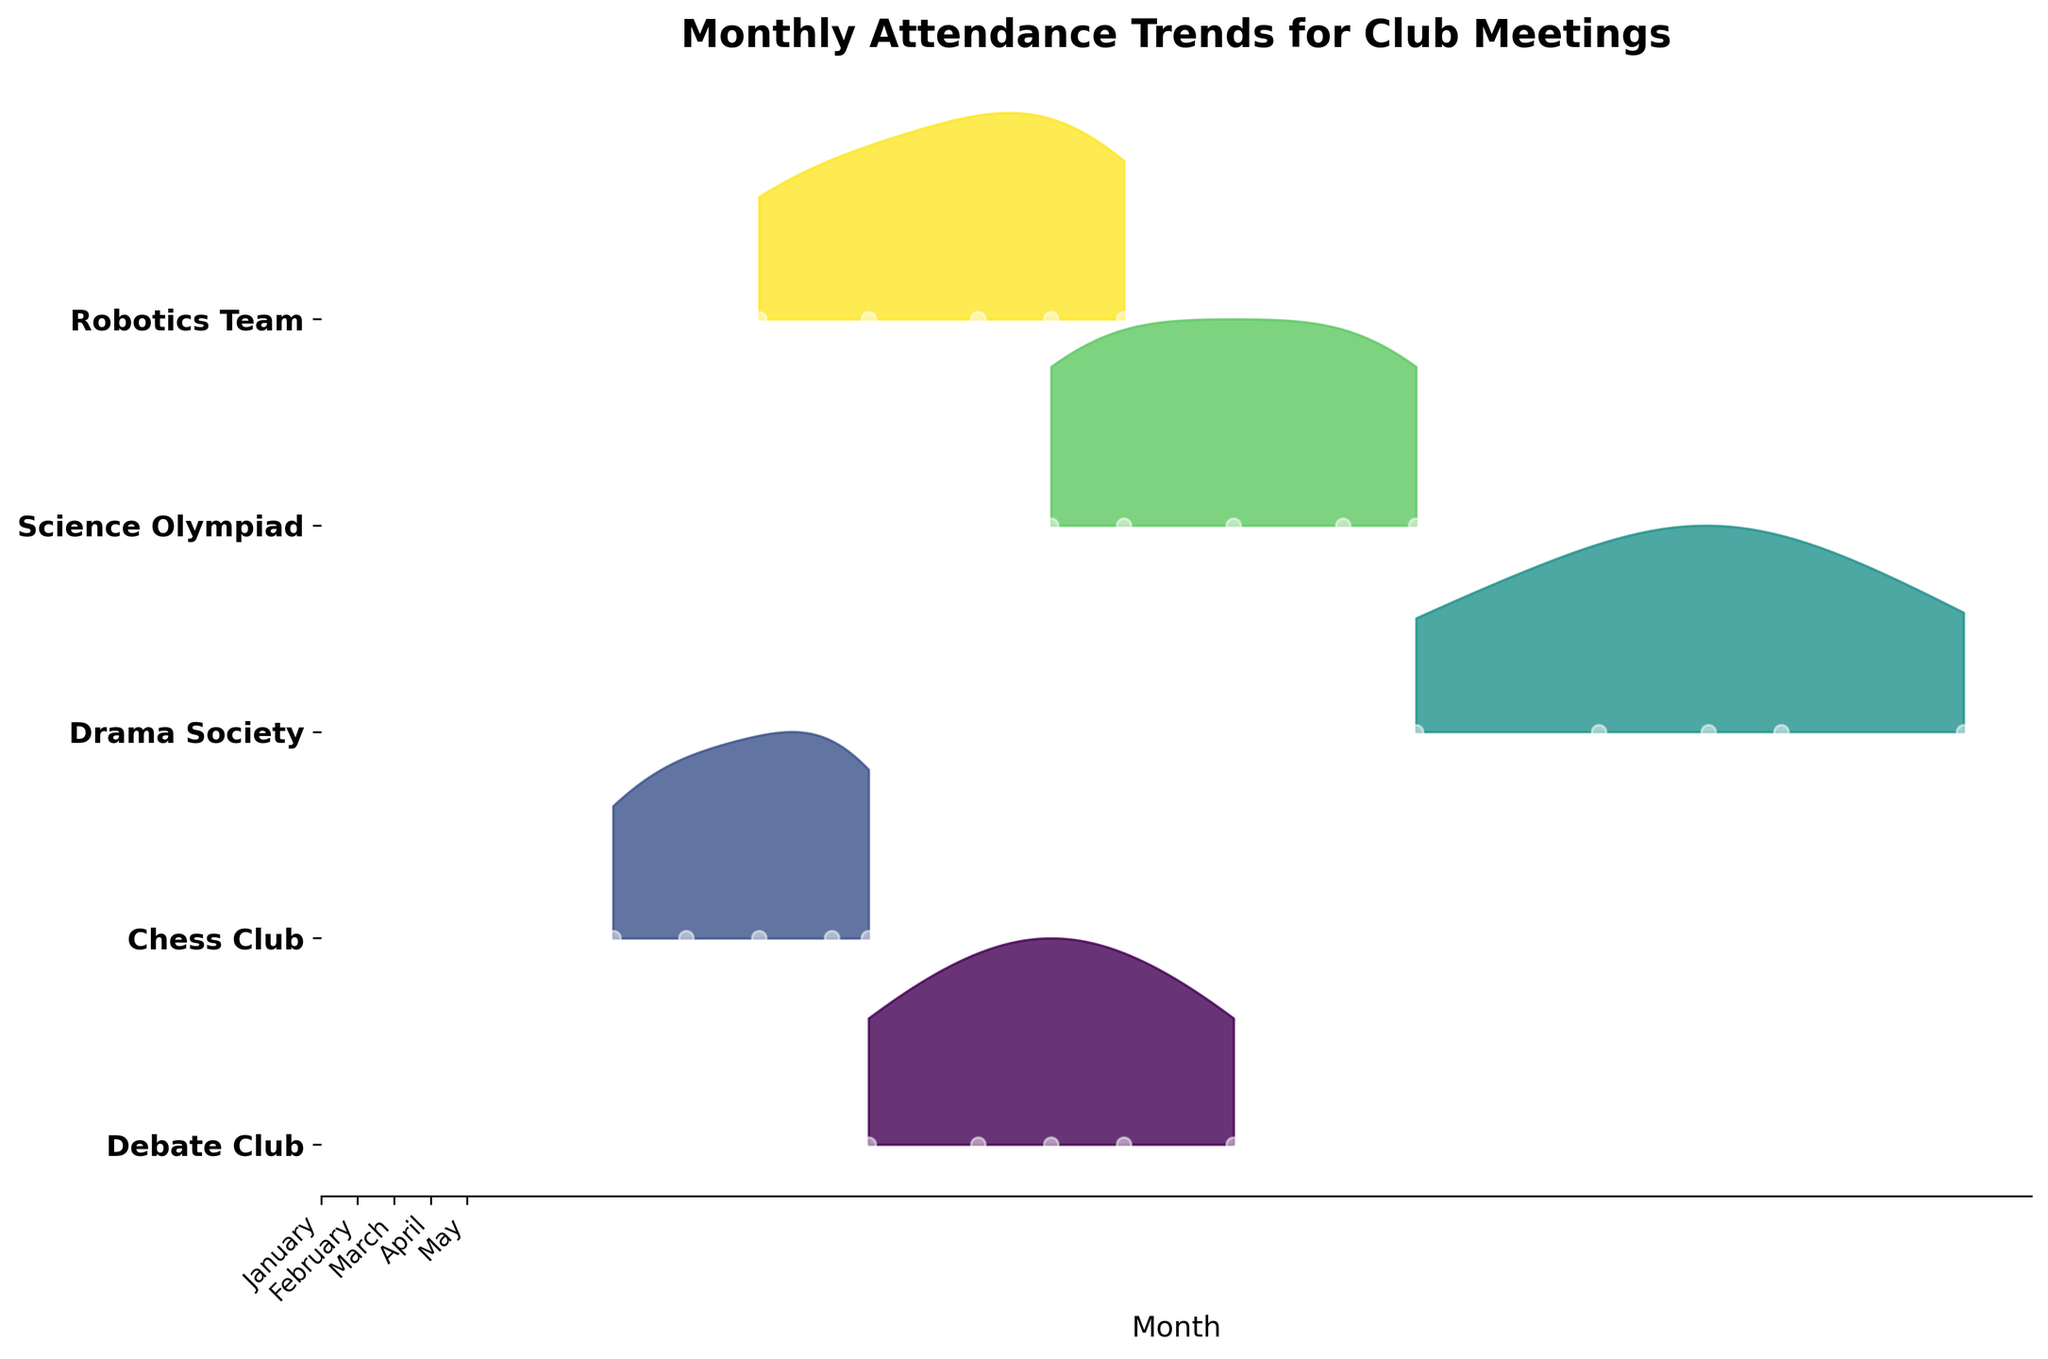What's the title of the plot? The title of the plot is usually placed at the top and describes the main subject of the visualization. From the plot, read the text that is bold and centered at the top.
Answer: Monthly Attendance Trends for Club Meetings How many clubs are represented in the plot? Each ridgeline represents a different club, and the number of ridgelines corresponds to the number of clubs. Count the ridgelines to get the total number of clubs.
Answer: 5 Which club has the highest attendance in May? Identify the ridgeline for each club and locate the point for May, then compare the heights of these points. The club with the point at the highest value on the y-axis has the highest attendance for May.
Answer: Drama Society Which club had the lowest attendance in January? Locate the ridgelines for each club and find the point for January. Compare the y-values for these points. The club with the lowest y-value point has the lowest attendance in January.
Answer: Chess Club What trend do you notice in the Science Olympiad's attendance from January to May? To notice the trend, trace the Science Olympiad ridgeline from January to May and observe the changes in height. The specific change in height indicates whether attendance is increasing, decreasing, or stable.
Answer: Increasing Compare the attendance trend of the Debate Club and Robotics Team over the months. What do you observe? Check the heights of the points for each month along the ridgelines for Debate Club and Robotics Team. Compare the trends by observing if they're both increasing, decreasing, or if one is increasing while the other is decreasing.
Answer: Both are increasing Which months show the highest variability in attendance for the Drama Society? Variability is indicated by the spread of the values along the x-axis. For Drama Society, observe which months show wider spreads and higher peaks on the ridgeline.
Answer: March and May How does the attendance in Chess Club change from February to April? Track the points for February, March, and April along the Chess Club ridgeline. Observe whether the points move up or down the y-axis, indicating an increase or decrease in attendance.
Answer: Increasing What can you infer about Robotics Team's attendance trend from January to May? Look at the sequence of points from January to May along the Robotics Team ridgeline and note the overall change in height. This pattern will indicate the trend.
Answer: Increasing Between Chess Club and Science Olympiad, which club had a more consistent attendance pattern over the months? Consistency is indicated by less variability in the ridgeline’s height over the months. Compare the smoothness of the ridgelines for Chess Club and Science Olympiad to see which has fewer fluctuations.
Answer: Science Olympiad 